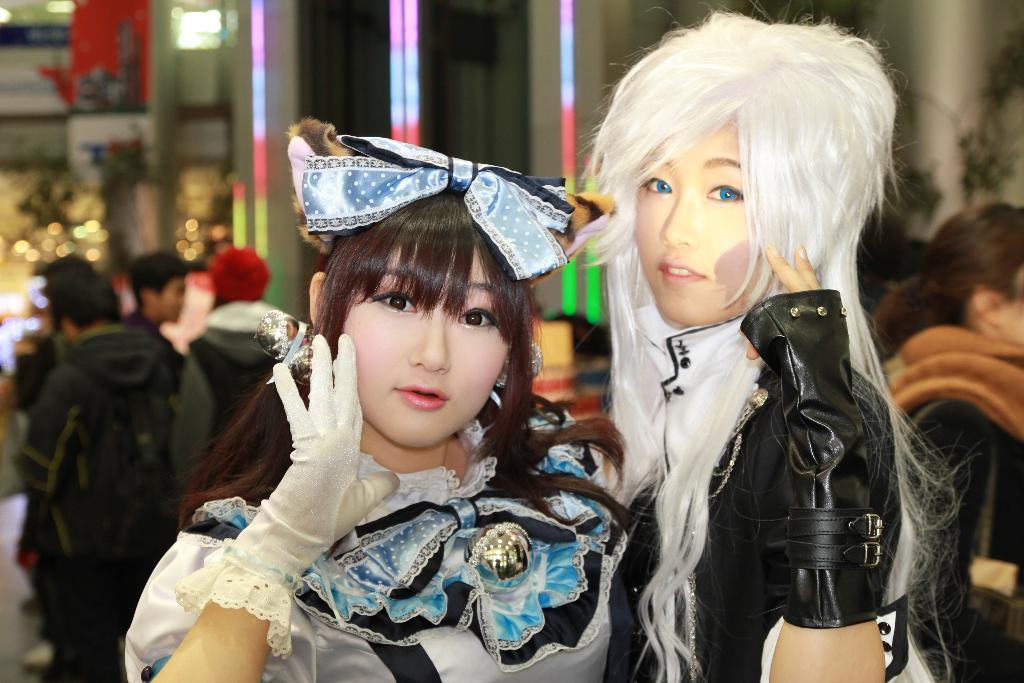Who or what can be seen in the image? There are people in the image. What can be seen in the background of the image? There are lights visible in the background of the image. What type of pen is being used by the people in the image? There is no pen visible in the image, as the focus is on the people and the lights in the background. 